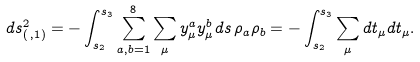<formula> <loc_0><loc_0><loc_500><loc_500>d s _ { ( \, , 1 ) } ^ { 2 } = - \int _ { s _ { 2 } } ^ { s _ { 3 } } \sum _ { a , b = 1 } ^ { 8 } \sum _ { \mu } { y } _ { \mu } ^ { a } { y } _ { \mu } ^ { b } d s \, \rho _ { a } \rho _ { b } = - \int _ { s _ { 2 } } ^ { s _ { 3 } } \sum _ { \mu } d { t } _ { \mu } d { t } _ { \mu } .</formula> 